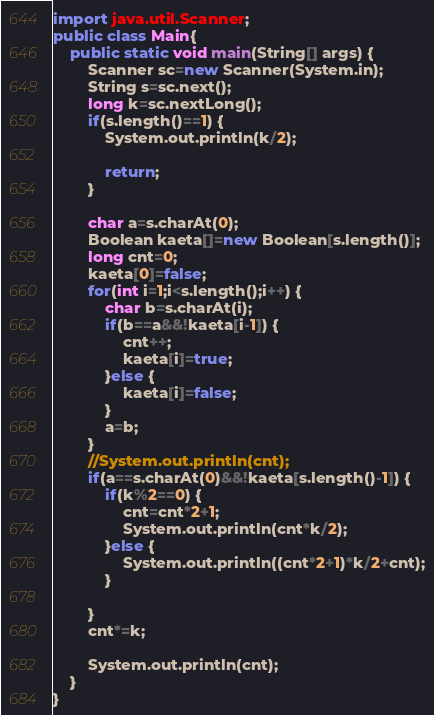<code> <loc_0><loc_0><loc_500><loc_500><_Java_>import java.util.Scanner;
public class Main{
	public static void main(String[] args) {
		Scanner sc=new Scanner(System.in);
		String s=sc.next();
		long k=sc.nextLong();
		if(s.length()==1) {
			System.out.println(k/2);

			return;
		}

		char a=s.charAt(0);
		Boolean kaeta[]=new Boolean[s.length()];
		long cnt=0;
		kaeta[0]=false;
		for(int i=1;i<s.length();i++) {
			char b=s.charAt(i);
			if(b==a&&!kaeta[i-1]) {
				cnt++;
				kaeta[i]=true;
			}else {
				kaeta[i]=false;
			}
			a=b;
		}
		//System.out.println(cnt);
		if(a==s.charAt(0)&&!kaeta[s.length()-1]) {
			if(k%2==0) {
				cnt=cnt*2+1;
				System.out.println(cnt*k/2);
			}else {
				System.out.println((cnt*2+1)*k/2+cnt);
			}

		}
		cnt*=k;

		System.out.println(cnt);
	}
}
</code> 